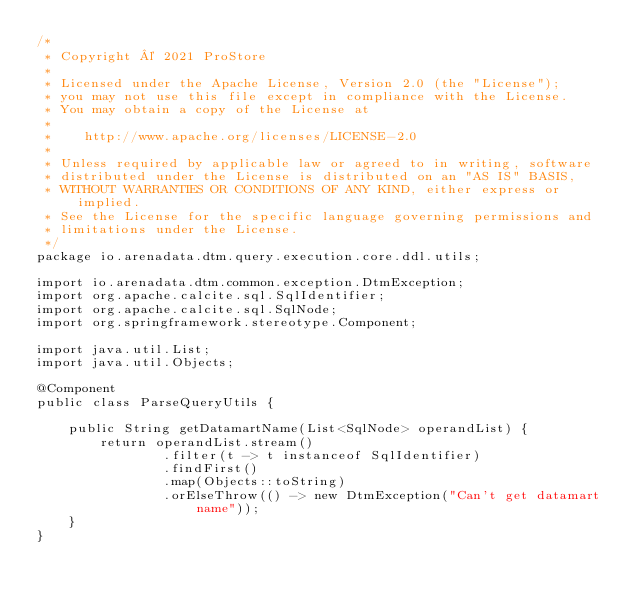Convert code to text. <code><loc_0><loc_0><loc_500><loc_500><_Java_>/*
 * Copyright © 2021 ProStore
 *
 * Licensed under the Apache License, Version 2.0 (the "License");
 * you may not use this file except in compliance with the License.
 * You may obtain a copy of the License at
 *
 *    http://www.apache.org/licenses/LICENSE-2.0
 *
 * Unless required by applicable law or agreed to in writing, software
 * distributed under the License is distributed on an "AS IS" BASIS,
 * WITHOUT WARRANTIES OR CONDITIONS OF ANY KIND, either express or implied.
 * See the License for the specific language governing permissions and
 * limitations under the License.
 */
package io.arenadata.dtm.query.execution.core.ddl.utils;

import io.arenadata.dtm.common.exception.DtmException;
import org.apache.calcite.sql.SqlIdentifier;
import org.apache.calcite.sql.SqlNode;
import org.springframework.stereotype.Component;

import java.util.List;
import java.util.Objects;

@Component
public class ParseQueryUtils {

    public String getDatamartName(List<SqlNode> operandList) {
        return operandList.stream()
                .filter(t -> t instanceof SqlIdentifier)
                .findFirst()
                .map(Objects::toString)
                .orElseThrow(() -> new DtmException("Can't get datamart name"));
    }
}
</code> 